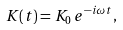Convert formula to latex. <formula><loc_0><loc_0><loc_500><loc_500>K ( t ) = K _ { 0 } \, e ^ { - i \omega t } ,</formula> 